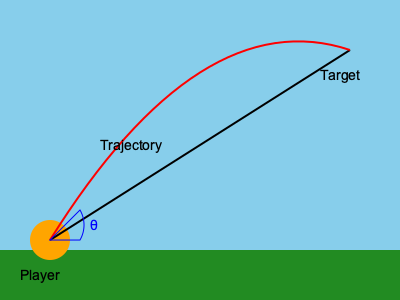As a dedicated Alumni football squad supporter, you understand the importance of a well-executed kick-off. Based on the diagram, what is the optimal angle θ for a football kick-off to achieve maximum distance, assuming no air resistance? To determine the optimal angle for a football kick-off to achieve maximum distance, we need to consider the principles of projectile motion. Here's a step-by-step explanation:

1. In projectile motion without air resistance, the trajectory of the ball follows a parabolic path.

2. The range (R) of a projectile is given by the formula:
   
   $R = \frac{v^2 \sin(2\theta)}{g}$

   Where:
   - $v$ is the initial velocity
   - $\theta$ is the launch angle
   - $g$ is the acceleration due to gravity

3. To maximize the range, we need to maximize $\sin(2\theta)$.

4. The sine function reaches its maximum value of 1 when its argument is 90°.

5. Therefore, for maximum range:
   
   $2\theta = 90°$

6. Solving for θ:
   
   $\theta = 45°$

7. This result is independent of the initial velocity and the acceleration due to gravity, making it universally applicable for projectile motion without air resistance.

In reality, factors like air resistance and the shape of the football can slightly alter this optimal angle, but 45° remains a good approximation for maximum distance in most kick-off situations.
Answer: 45° 